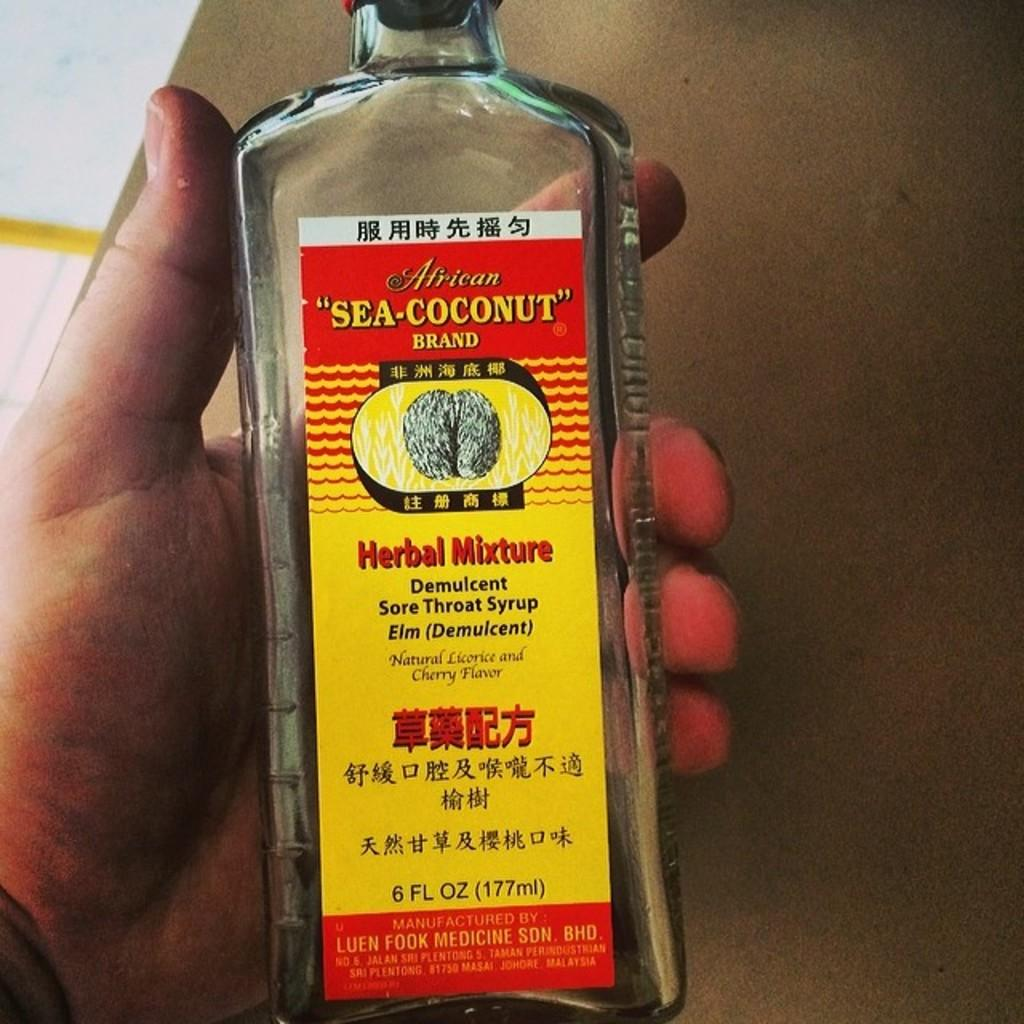Who or what is present in the image? There is a person in the image. What is the person holding in the image? The person is holding a bottle. What is written on the bottle? The bottle has "sea-coconut" written on it. What type of dog can be seen singing a song in the image? There is no dog or song present in the image; it features a person holding a bottle with "sea-coconut" written on it. 